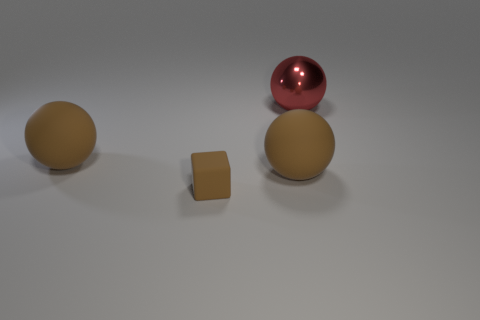What number of small things are either brown cylinders or red shiny objects? In the image, there are no brown cylinders, but there is one small red shiny sphere. So the number of small things that are either brown cylinders or red shiny objects is one. 